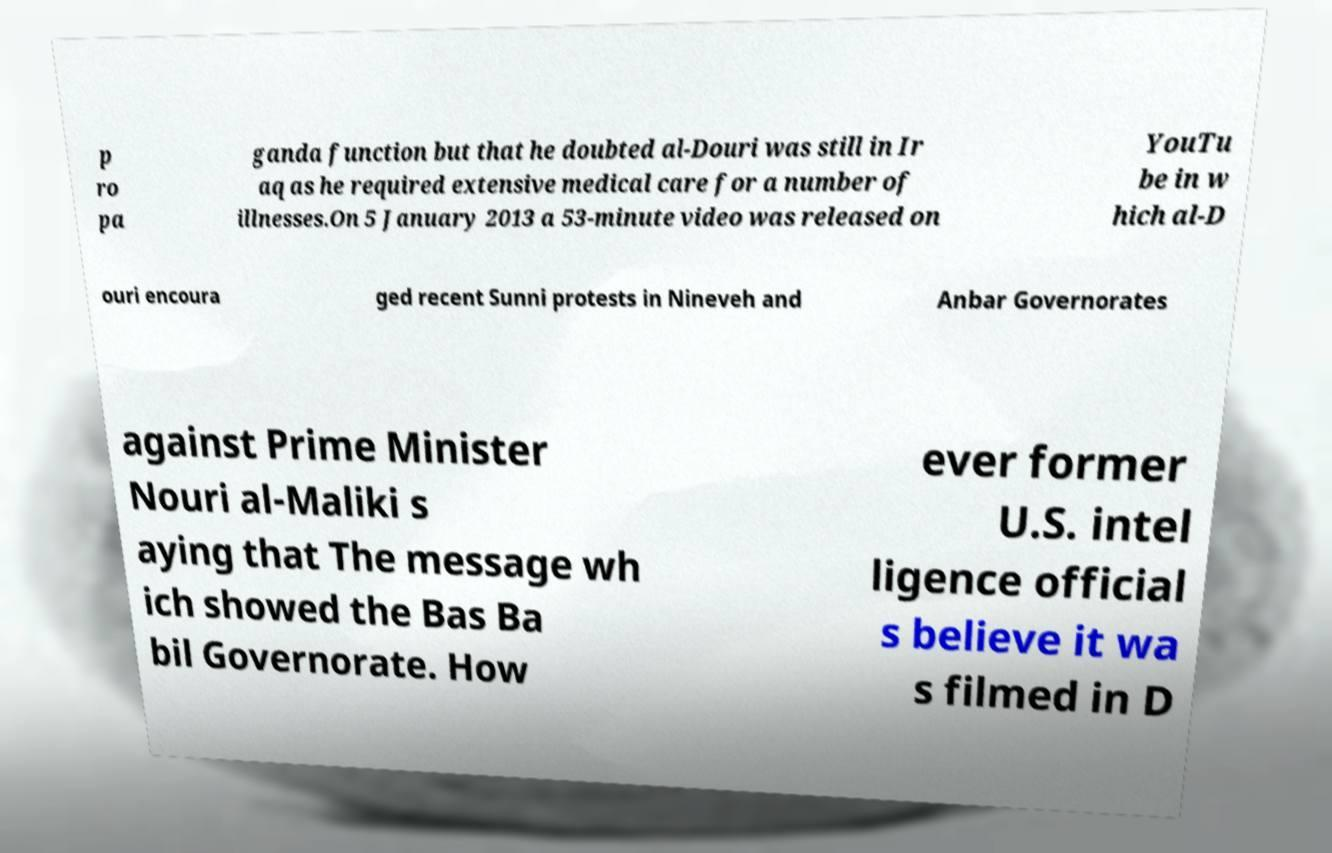Can you read and provide the text displayed in the image?This photo seems to have some interesting text. Can you extract and type it out for me? p ro pa ganda function but that he doubted al-Douri was still in Ir aq as he required extensive medical care for a number of illnesses.On 5 January 2013 a 53-minute video was released on YouTu be in w hich al-D ouri encoura ged recent Sunni protests in Nineveh and Anbar Governorates against Prime Minister Nouri al-Maliki s aying that The message wh ich showed the Bas Ba bil Governorate. How ever former U.S. intel ligence official s believe it wa s filmed in D 